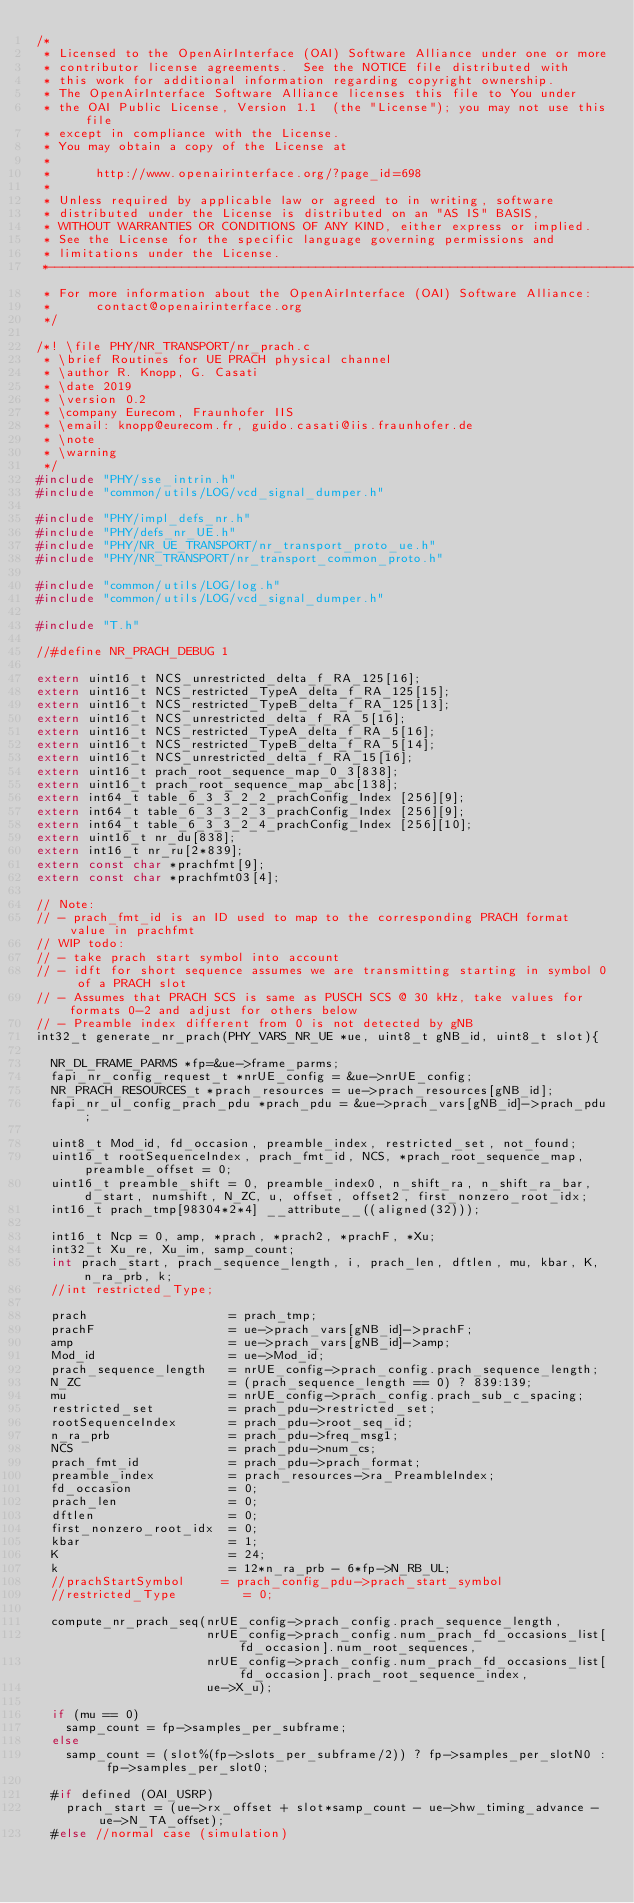Convert code to text. <code><loc_0><loc_0><loc_500><loc_500><_C_>/*
 * Licensed to the OpenAirInterface (OAI) Software Alliance under one or more
 * contributor license agreements.  See the NOTICE file distributed with
 * this work for additional information regarding copyright ownership.
 * The OpenAirInterface Software Alliance licenses this file to You under
 * the OAI Public License, Version 1.1  (the "License"); you may not use this file
 * except in compliance with the License.
 * You may obtain a copy of the License at
 *
 *      http://www.openairinterface.org/?page_id=698
 *
 * Unless required by applicable law or agreed to in writing, software
 * distributed under the License is distributed on an "AS IS" BASIS,
 * WITHOUT WARRANTIES OR CONDITIONS OF ANY KIND, either express or implied.
 * See the License for the specific language governing permissions and
 * limitations under the License.
 *-------------------------------------------------------------------------------
 * For more information about the OpenAirInterface (OAI) Software Alliance:
 *      contact@openairinterface.org
 */

/*! \file PHY/NR_TRANSPORT/nr_prach.c
 * \brief Routines for UE PRACH physical channel
 * \author R. Knopp, G. Casati
 * \date 2019
 * \version 0.2
 * \company Eurecom, Fraunhofer IIS
 * \email: knopp@eurecom.fr, guido.casati@iis.fraunhofer.de
 * \note
 * \warning
 */
#include "PHY/sse_intrin.h"
#include "common/utils/LOG/vcd_signal_dumper.h"

#include "PHY/impl_defs_nr.h"
#include "PHY/defs_nr_UE.h"
#include "PHY/NR_UE_TRANSPORT/nr_transport_proto_ue.h"
#include "PHY/NR_TRANSPORT/nr_transport_common_proto.h"

#include "common/utils/LOG/log.h"
#include "common/utils/LOG/vcd_signal_dumper.h"

#include "T.h"

//#define NR_PRACH_DEBUG 1

extern uint16_t NCS_unrestricted_delta_f_RA_125[16];
extern uint16_t NCS_restricted_TypeA_delta_f_RA_125[15];
extern uint16_t NCS_restricted_TypeB_delta_f_RA_125[13];
extern uint16_t NCS_unrestricted_delta_f_RA_5[16];
extern uint16_t NCS_restricted_TypeA_delta_f_RA_5[16];
extern uint16_t NCS_restricted_TypeB_delta_f_RA_5[14];
extern uint16_t NCS_unrestricted_delta_f_RA_15[16];
extern uint16_t prach_root_sequence_map_0_3[838];
extern uint16_t prach_root_sequence_map_abc[138];
extern int64_t table_6_3_3_2_2_prachConfig_Index [256][9];
extern int64_t table_6_3_3_2_3_prachConfig_Index [256][9];
extern int64_t table_6_3_3_2_4_prachConfig_Index [256][10];
extern uint16_t nr_du[838];
extern int16_t nr_ru[2*839];
extern const char *prachfmt[9];
extern const char *prachfmt03[4];

// Note:
// - prach_fmt_id is an ID used to map to the corresponding PRACH format value in prachfmt
// WIP todo:
// - take prach start symbol into account
// - idft for short sequence assumes we are transmitting starting in symbol 0 of a PRACH slot
// - Assumes that PRACH SCS is same as PUSCH SCS @ 30 kHz, take values for formats 0-2 and adjust for others below
// - Preamble index different from 0 is not detected by gNB
int32_t generate_nr_prach(PHY_VARS_NR_UE *ue, uint8_t gNB_id, uint8_t slot){

  NR_DL_FRAME_PARMS *fp=&ue->frame_parms;
  fapi_nr_config_request_t *nrUE_config = &ue->nrUE_config;
  NR_PRACH_RESOURCES_t *prach_resources = ue->prach_resources[gNB_id];
  fapi_nr_ul_config_prach_pdu *prach_pdu = &ue->prach_vars[gNB_id]->prach_pdu;

  uint8_t Mod_id, fd_occasion, preamble_index, restricted_set, not_found;
  uint16_t rootSequenceIndex, prach_fmt_id, NCS, *prach_root_sequence_map, preamble_offset = 0;
  uint16_t preamble_shift = 0, preamble_index0, n_shift_ra, n_shift_ra_bar, d_start, numshift, N_ZC, u, offset, offset2, first_nonzero_root_idx;
  int16_t prach_tmp[98304*2*4] __attribute__((aligned(32)));

  int16_t Ncp = 0, amp, *prach, *prach2, *prachF, *Xu;
  int32_t Xu_re, Xu_im, samp_count;
  int prach_start, prach_sequence_length, i, prach_len, dftlen, mu, kbar, K, n_ra_prb, k;
  //int restricted_Type;

  prach                   = prach_tmp;
  prachF                  = ue->prach_vars[gNB_id]->prachF;
  amp                     = ue->prach_vars[gNB_id]->amp;
  Mod_id                  = ue->Mod_id;
  prach_sequence_length   = nrUE_config->prach_config.prach_sequence_length;
  N_ZC                    = (prach_sequence_length == 0) ? 839:139;
  mu                      = nrUE_config->prach_config.prach_sub_c_spacing;
  restricted_set          = prach_pdu->restricted_set;
  rootSequenceIndex       = prach_pdu->root_seq_id;
  n_ra_prb                = prach_pdu->freq_msg1;
  NCS                     = prach_pdu->num_cs;
  prach_fmt_id            = prach_pdu->prach_format;
  preamble_index          = prach_resources->ra_PreambleIndex;
  fd_occasion             = 0;
  prach_len               = 0;
  dftlen                  = 0;
  first_nonzero_root_idx  = 0;
  kbar                    = 1;
  K                       = 24;
  k                       = 12*n_ra_prb - 6*fp->N_RB_UL;
  //prachStartSymbol     = prach_config_pdu->prach_start_symbol
  //restricted_Type         = 0;

  compute_nr_prach_seq(nrUE_config->prach_config.prach_sequence_length,
                       nrUE_config->prach_config.num_prach_fd_occasions_list[fd_occasion].num_root_sequences,
                       nrUE_config->prach_config.num_prach_fd_occasions_list[fd_occasion].prach_root_sequence_index,
                       ue->X_u);

  if (mu == 0)
    samp_count = fp->samples_per_subframe;
  else
    samp_count = (slot%(fp->slots_per_subframe/2)) ? fp->samples_per_slotN0 : fp->samples_per_slot0;

  #if defined (OAI_USRP)
    prach_start = (ue->rx_offset + slot*samp_count - ue->hw_timing_advance - ue->N_TA_offset);
  #else //normal case (simulation)</code> 